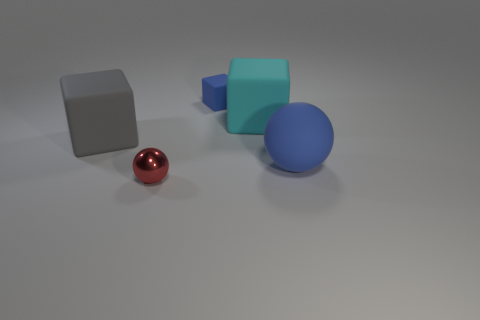Subtract all big cubes. How many cubes are left? 1 Add 2 tiny purple spheres. How many objects exist? 7 Subtract all balls. How many objects are left? 3 Subtract all blue cubes. How many cubes are left? 2 Subtract all large green metal spheres. Subtract all big gray rubber cubes. How many objects are left? 4 Add 2 small blue cubes. How many small blue cubes are left? 3 Add 4 purple metallic cylinders. How many purple metallic cylinders exist? 4 Subtract 1 gray cubes. How many objects are left? 4 Subtract all blue balls. Subtract all yellow cylinders. How many balls are left? 1 Subtract all gray blocks. How many purple balls are left? 0 